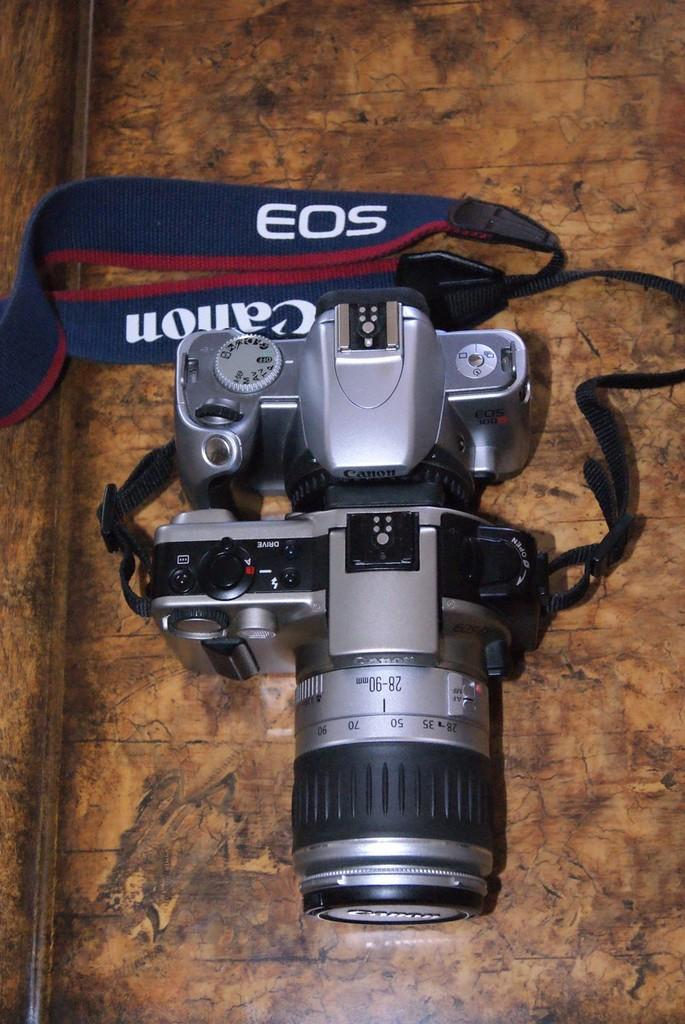What object is the main subject of the image? There is a camera in the image. Where is the camera located? The camera is on a surface. What feature is attached to the camera? The camera has a strap. What is written on the strap? There is writing on the strap. Can you tell me how many horses are depicted on the camera strap? There are no horses depicted on the camera strap; the facts do not mention any horses. What type of brush is used to clean the camera lens in the image? There is no brush present in the image, and the facts do not mention any cleaning activity. 